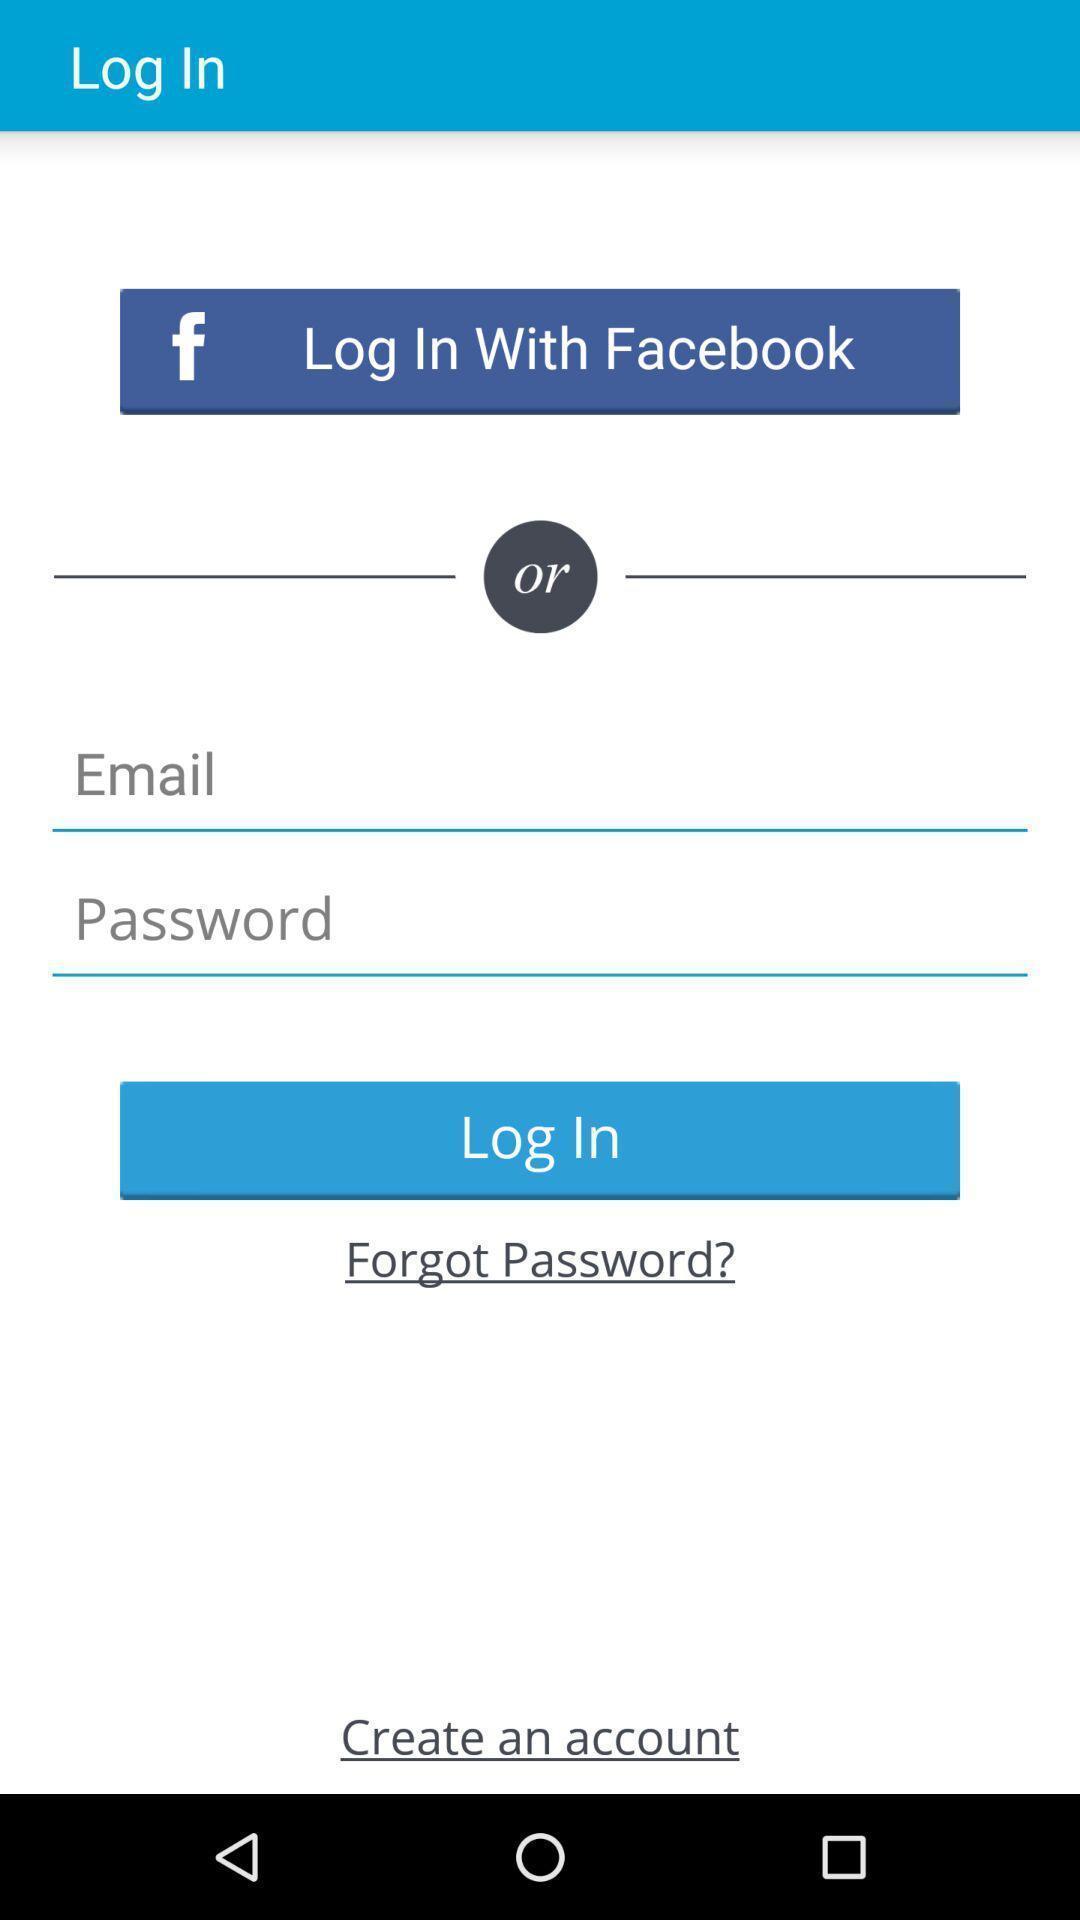Summarize the information in this screenshot. Welcome page of a social application. 